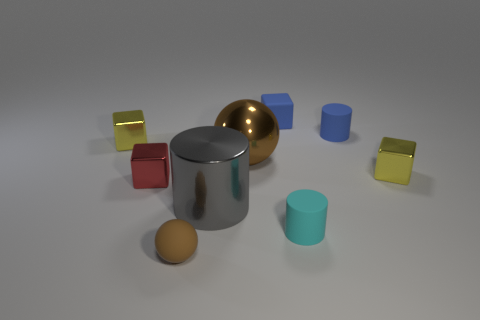There is a object that is both in front of the gray object and left of the large gray shiny thing; how big is it?
Provide a succinct answer. Small. How many other things are there of the same shape as the tiny red metallic thing?
Offer a very short reply. 3. There is a red metal block; what number of big shiny spheres are in front of it?
Your answer should be compact. 0. Are there fewer yellow things to the left of the gray thing than brown matte objects behind the tiny cyan matte cylinder?
Give a very brief answer. No. There is a large object in front of the tiny yellow block that is on the right side of the small yellow object on the left side of the large metallic cylinder; what is its shape?
Make the answer very short. Cylinder. The rubber thing that is both in front of the large ball and right of the brown matte object has what shape?
Offer a very short reply. Cylinder. Is there a big cylinder made of the same material as the small brown ball?
Your answer should be compact. No. The matte sphere that is the same color as the metallic sphere is what size?
Your answer should be compact. Small. What color is the sphere on the left side of the large shiny sphere?
Make the answer very short. Brown. There is a brown metal thing; does it have the same shape as the tiny brown rubber thing that is left of the cyan cylinder?
Your answer should be compact. Yes. 